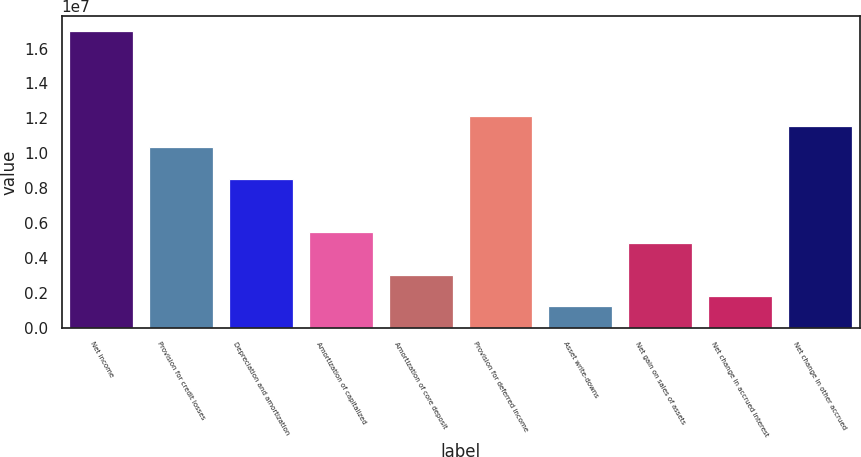Convert chart to OTSL. <chart><loc_0><loc_0><loc_500><loc_500><bar_chart><fcel>Net income<fcel>Provision for credit losses<fcel>Depreciation and amortization<fcel>Amortization of capitalized<fcel>Amortization of core deposit<fcel>Provision for deferred income<fcel>Asset write-downs<fcel>Net gain on sales of assets<fcel>Net change in accrued interest<fcel>Net change in other accrued<nl><fcel>1.70135e+07<fcel>1.03298e+07<fcel>8.50696e+06<fcel>5.46891e+06<fcel>3.03847e+06<fcel>1.21526e+07<fcel>1.21564e+06<fcel>4.8613e+06<fcel>1.82325e+06<fcel>1.1545e+07<nl></chart> 